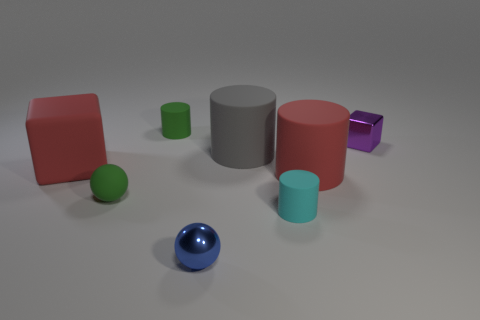Add 1 big gray metal objects. How many objects exist? 9 Subtract all cubes. How many objects are left? 6 Add 3 tiny yellow matte spheres. How many tiny yellow matte spheres exist? 3 Subtract 0 purple cylinders. How many objects are left? 8 Subtract all blue metal balls. Subtract all big cylinders. How many objects are left? 5 Add 2 green rubber things. How many green rubber things are left? 4 